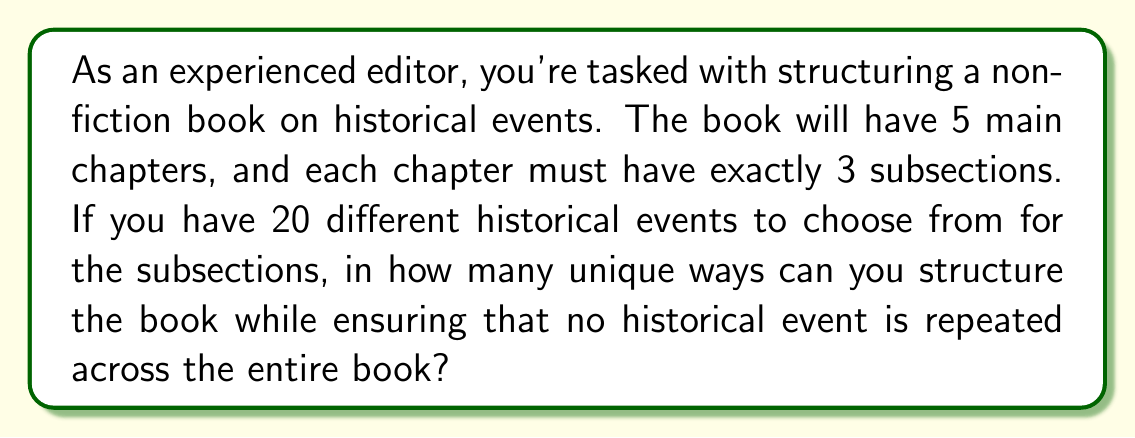Solve this math problem. Let's approach this step-by-step:

1) First, we need to choose 15 historical events out of 20 for our book (5 chapters × 3 subsections = 15 total subsections).
   This can be done in $\binom{20}{15}$ ways.

2) Now, we need to distribute these 15 chosen events into 5 chapters, with 3 events per chapter.
   This is a partition problem, specifically partitioning 15 distinct objects into 5 distinct groups of 3 each.

3) The number of ways to do this partition is given by the formula:
   $$\frac{15!}{(3!)^5}$$

4) Finally, within each chapter, the 3 events can be arranged in 3! ways.
   Since we have 5 chapters, we multiply by $(3!)^5$.

5) Putting it all together, the total number of unique ways to structure the book is:

   $$\binom{20}{15} \times \frac{15!}{(3!)^5} \times (3!)^5$$

6) Simplify:
   $$\frac{20!}{15!5!} \times 15!$$

7) The 15! cancels out:
   $$\frac{20!}{5!}$$

This final expression represents the number of unique ways to structure the book.
Answer: $$\frac{20!}{5!} = 311,875,200,000$$ 